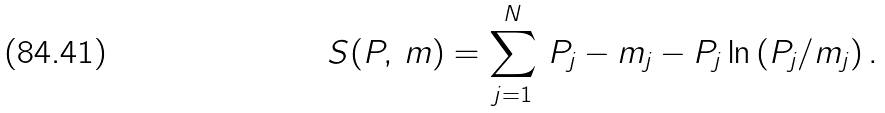<formula> <loc_0><loc_0><loc_500><loc_500>S ( P , \, m ) = \sum _ { j = 1 } ^ { N } \, P _ { j } - m _ { j } - P _ { j } \ln \left ( P _ { j } / m _ { j } \right ) .</formula> 